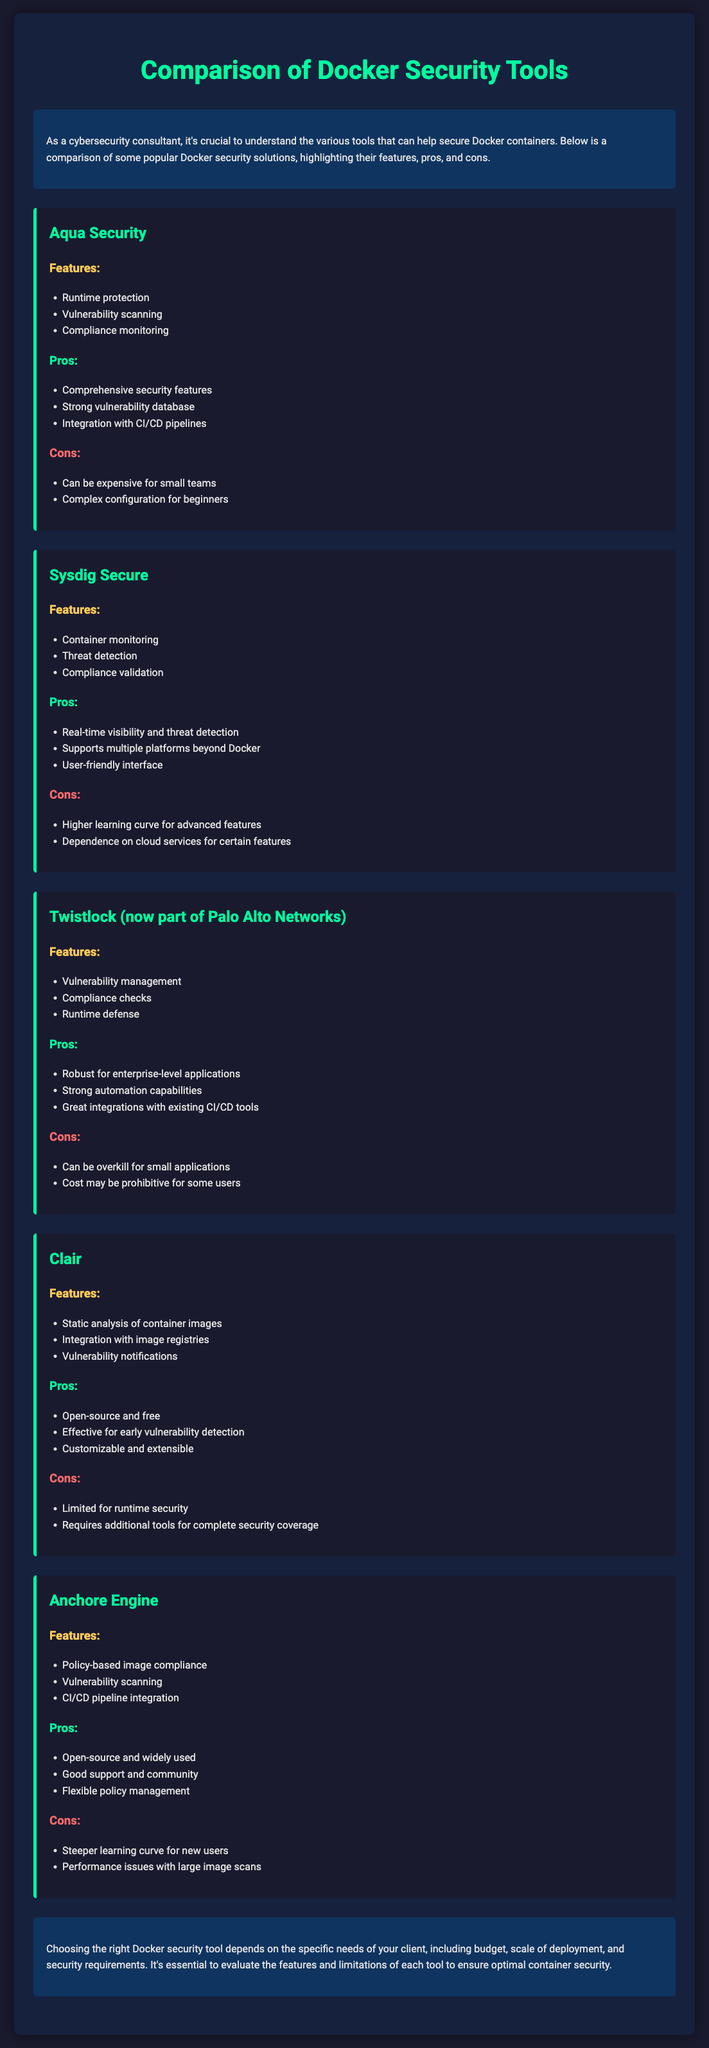What is the title of the document? The title is specified at the top of the document, indicating the subject matter.
Answer: Comparison of Docker Security Tools What are the features of Aqua Security? The features are listed under the section dedicated to Aqua Security, highlighting its capabilities.
Answer: Runtime protection, Vulnerability scanning, Compliance monitoring What is a con of using Sysdig Secure? The cons are provided to highlight potential drawbacks of Sysdig Secure, which are clearly enumerated.
Answer: Higher learning curve for advanced features What is the primary feature of Clair? The document lists the features of Clair, focusing on its main capabilities regarding container images.
Answer: Static analysis of container images Which tool is known for being open-source and free? The pros section of Clair mentions it is open-source and free, making it stand out among the tools.
Answer: Clair Which Docker security tool integrates with CI/CD pipelines? The document mentions several tools, providing information on which ones support integration with CI/CD processes.
Answer: Aqua Security, Twistlock, Anchore Engine What is a common con shared by Twistlock and Anchore Engine? By comparing the cons listed for both tools, we can identify shared setbacks.
Answer: Cost may be prohibitive for some users Which tool is suited for enterprise-level applications? The pros section of Twistlock specifically mentions its suitability for larger applications.
Answer: Twistlock What is the purpose of the conclusion section? The conclusion summarizes the overall advice given in the document regarding tool selection.
Answer: Evaluating features and limitations for optimal security 